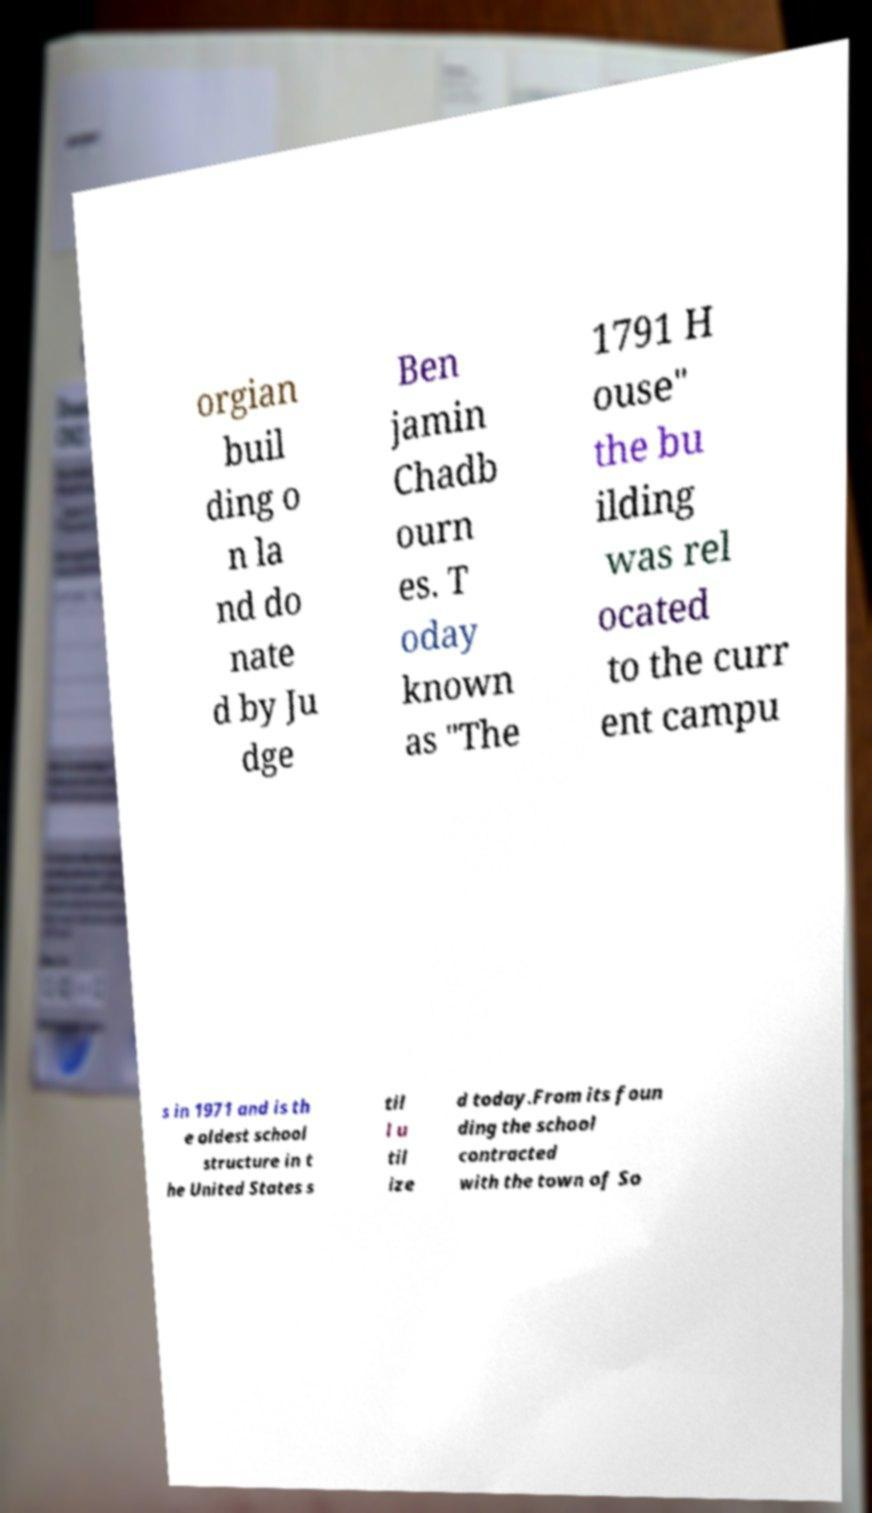I need the written content from this picture converted into text. Can you do that? orgian buil ding o n la nd do nate d by Ju dge Ben jamin Chadb ourn es. T oday known as "The 1791 H ouse" the bu ilding was rel ocated to the curr ent campu s in 1971 and is th e oldest school structure in t he United States s til l u til ize d today.From its foun ding the school contracted with the town of So 